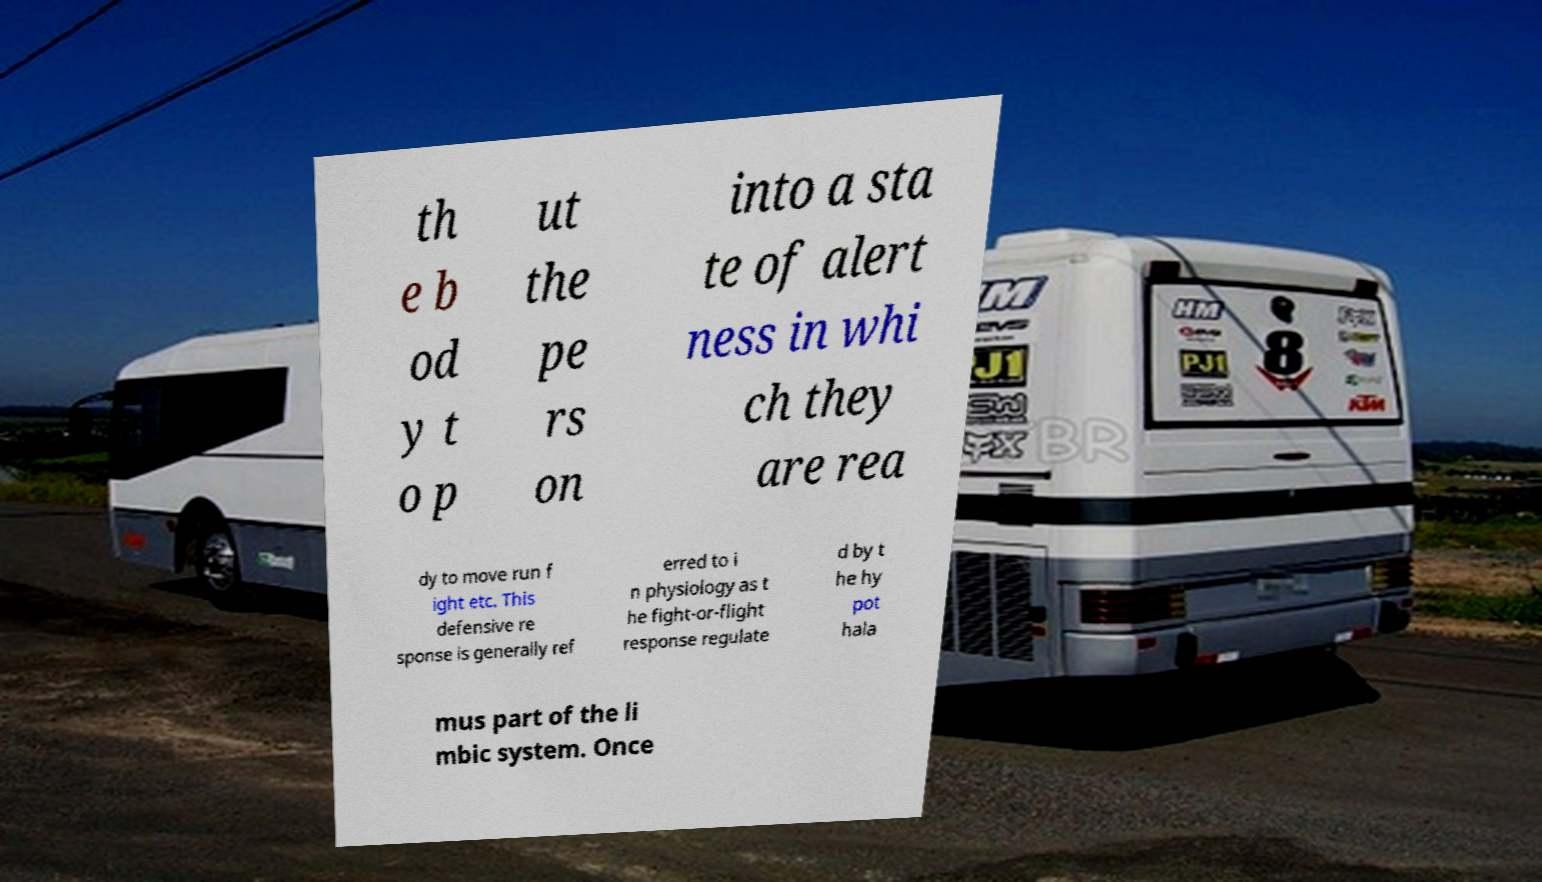Please read and relay the text visible in this image. What does it say? th e b od y t o p ut the pe rs on into a sta te of alert ness in whi ch they are rea dy to move run f ight etc. This defensive re sponse is generally ref erred to i n physiology as t he fight-or-flight response regulate d by t he hy pot hala mus part of the li mbic system. Once 